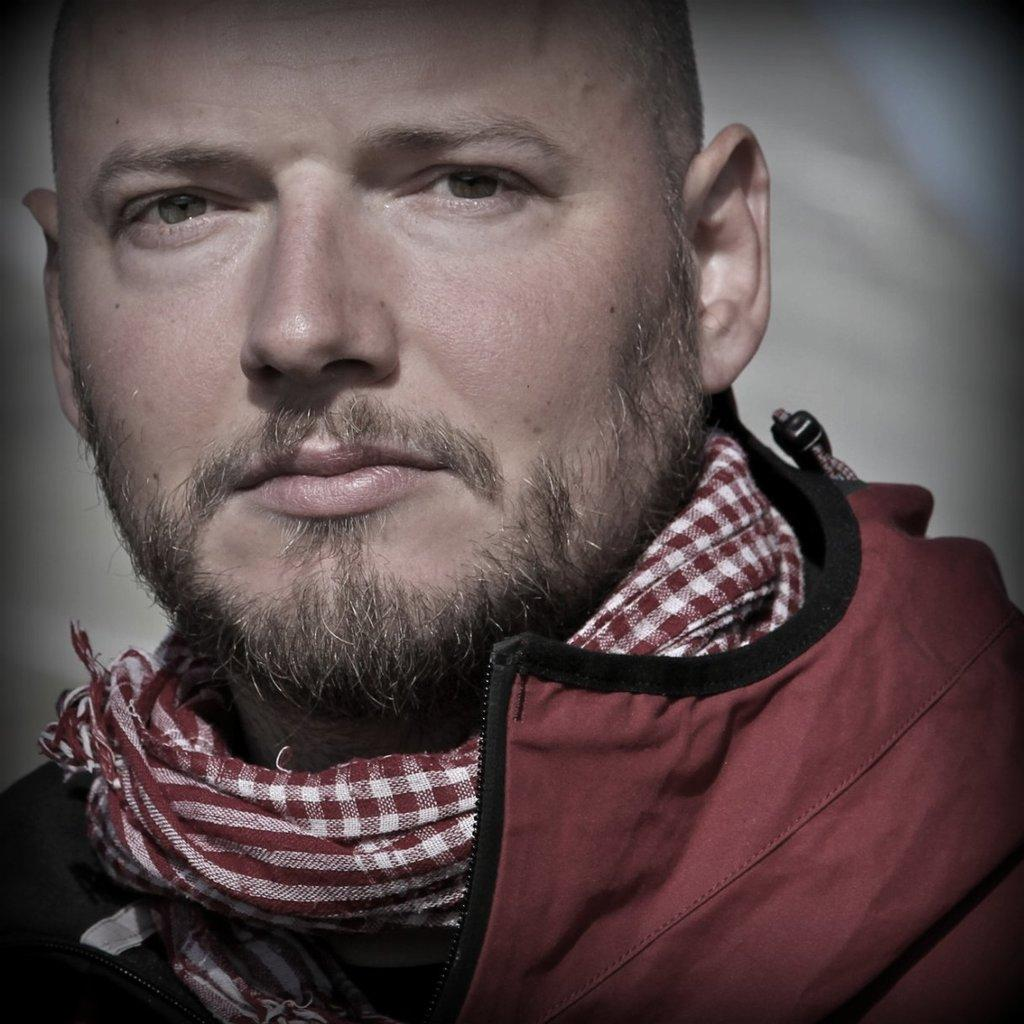Who is the main subject in the image? There is a man in the image. What is the man wearing? The man is wearing a red dress. Is there any accessory or clothing item around the man's neck? Yes, there is a cloth around the man's neck. How would you describe the background of the image? The background of the image is blurry. Can you see any grass in the image? There is no grass visible in the image. What type of face expression does the man have in the image? The image does not show the man's face, so it is not possible to determine his facial expression. 